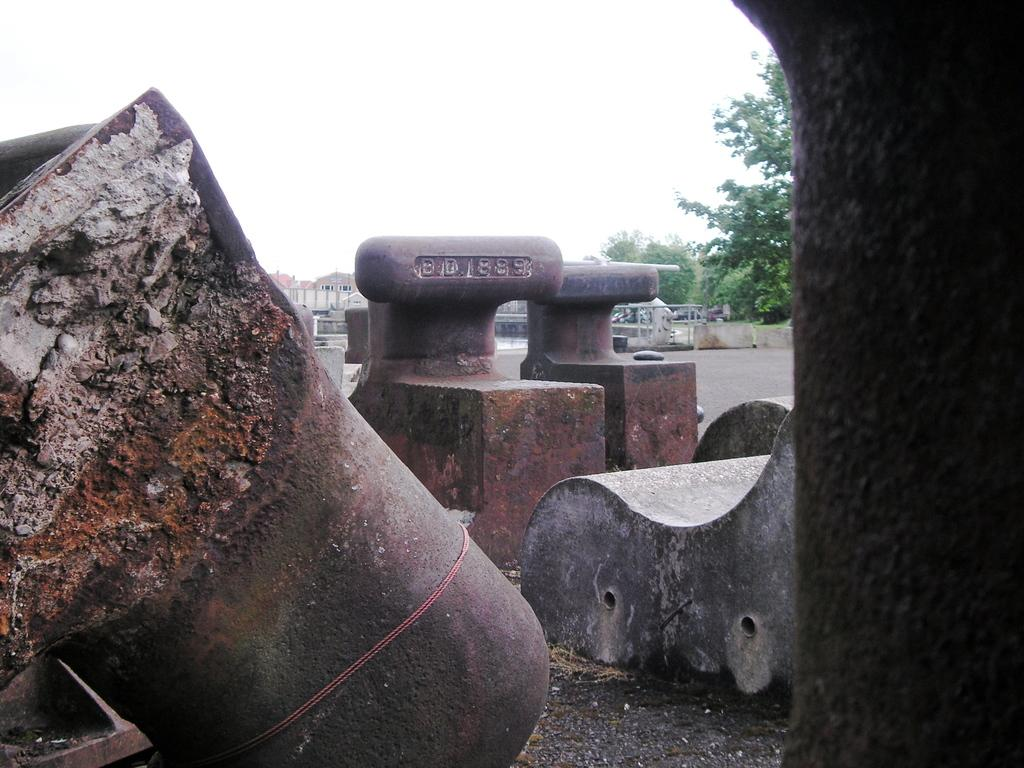What type of seating is visible in the image? There is a bench in the image. What can be found on the ground in the image? There are objects on the ground in the image. What is visible in the background of the image? There is a fence, houses, electric poles, trees, and the sky visible in the background of the image. How many copies of the hydrant are present in the image? There is no hydrant present in the image. What type of force is being applied to the pull the fence in the image? There is no force being applied to the fence in the image; it is stationary in the background. 